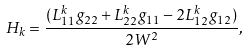Convert formula to latex. <formula><loc_0><loc_0><loc_500><loc_500>H _ { k } = \frac { ( L _ { 1 1 } ^ { k } g _ { 2 2 } + L _ { 2 2 } ^ { k } g _ { 1 1 } - 2 L _ { 1 2 } ^ { k } g _ { 1 2 } ) } { 2 W ^ { 2 } } ,</formula> 